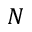<formula> <loc_0><loc_0><loc_500><loc_500>N</formula> 